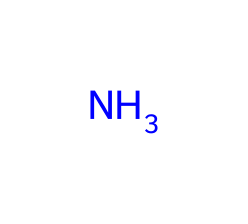What is the primary element in this chemical? The chemical structure shows a single nitrogen atom, indicating that it is primarily composed of nitrogen.
Answer: nitrogen How many hydrogen atoms are typically associated with ammonia? Ammonia commonly has three hydrogen atoms bonded to one nitrogen atom, making its standard formula NH3.
Answer: three What type of chemical is represented by this structure? This chemical, characterized by a nitrogen atom, is classified as a base specifically because it can accept protons (H+ ions).
Answer: base What is the charge of ammonia in solution? Ammonia is neutral in its encountered form and does not carry any net charge when dissolved in water.
Answer: neutral Why can ammonia be classified as a weak base? Ammonia's ability to accept protons is limited, thus it does not fully dissociate in solution, which is characteristic of weak bases.
Answer: weak What is the molecular formula for ammonia? The structure corresponds to NH3, which directly reveals the ratio of nitrogen to hydrogen atoms in the compound.
Answer: NH3 